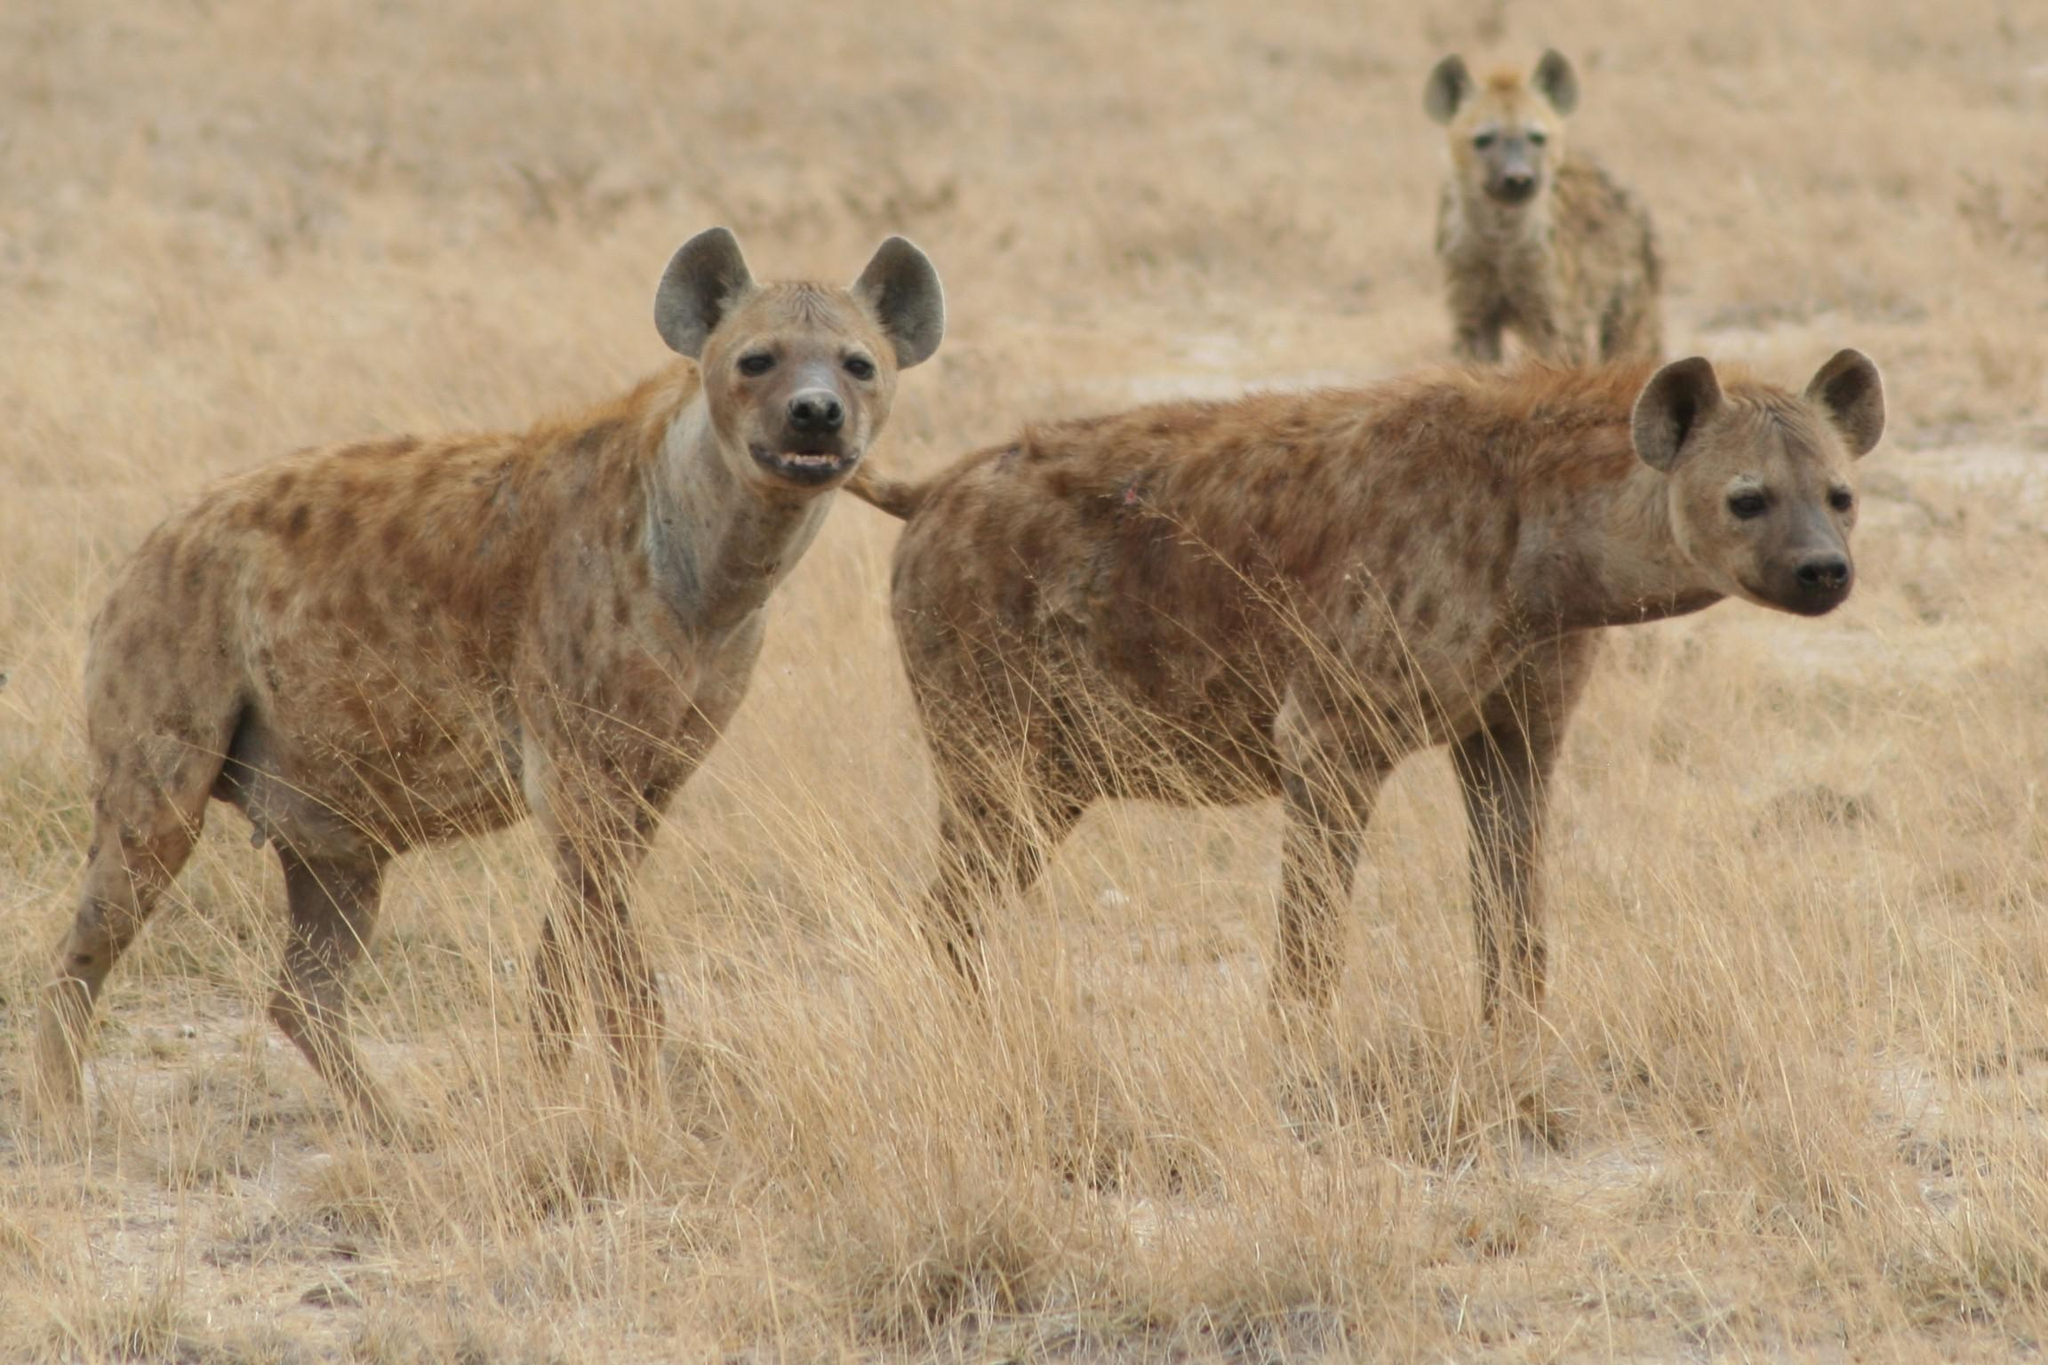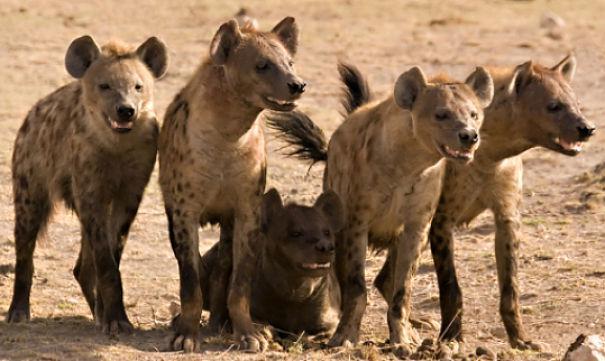The first image is the image on the left, the second image is the image on the right. Considering the images on both sides, is "One hyena sits while two stand on either side of it." valid? Answer yes or no. Yes. 